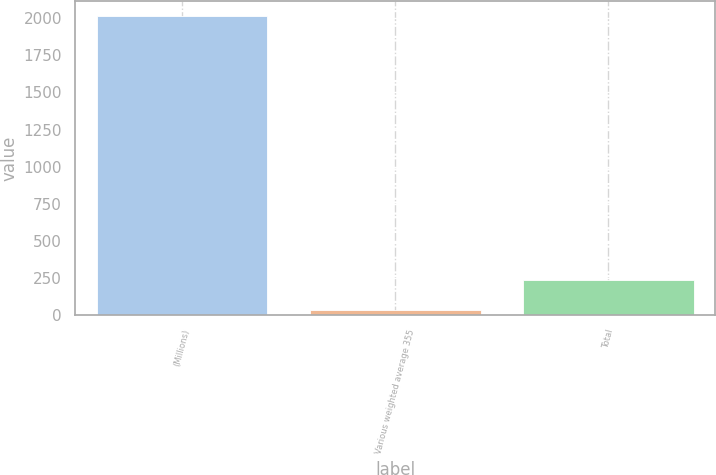<chart> <loc_0><loc_0><loc_500><loc_500><bar_chart><fcel>(Millions)<fcel>Various weighted average 355<fcel>Total<nl><fcel>2012<fcel>39<fcel>236.3<nl></chart> 